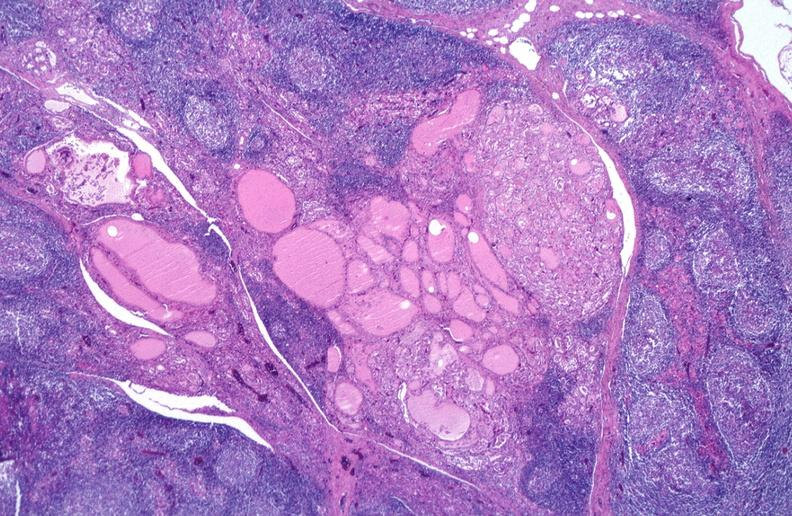s endocrine present?
Answer the question using a single word or phrase. Yes 